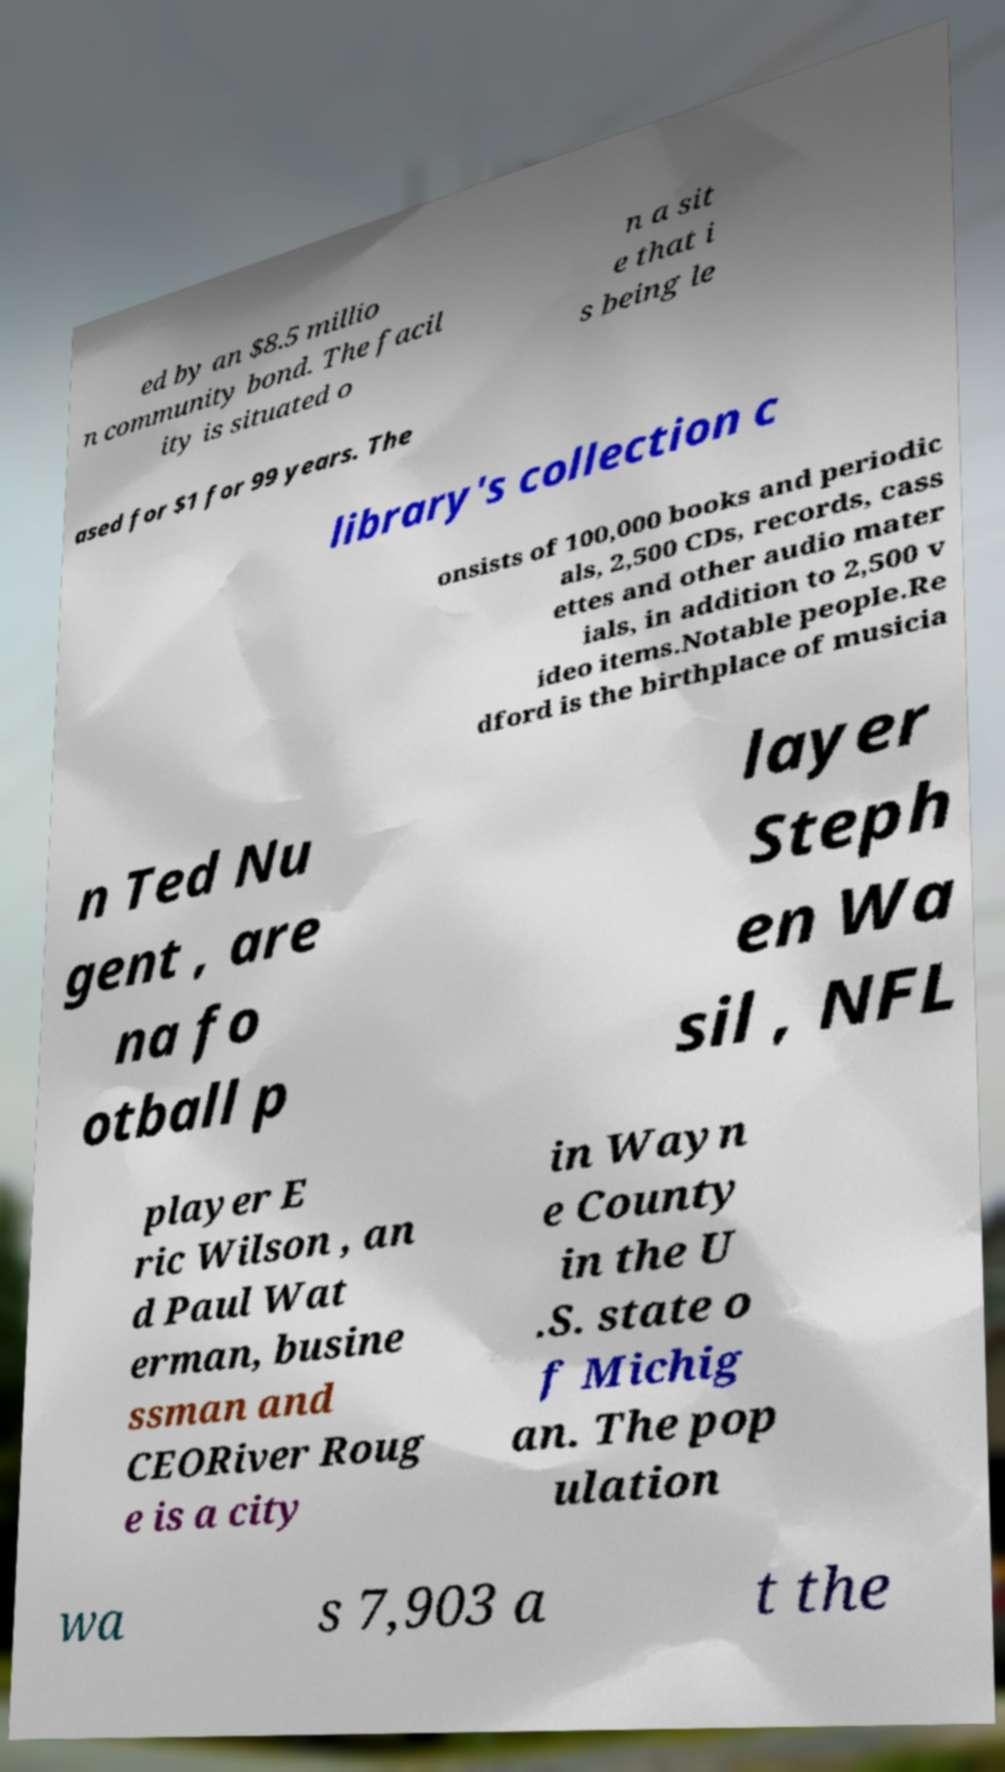I need the written content from this picture converted into text. Can you do that? ed by an $8.5 millio n community bond. The facil ity is situated o n a sit e that i s being le ased for $1 for 99 years. The library's collection c onsists of 100,000 books and periodic als, 2,500 CDs, records, cass ettes and other audio mater ials, in addition to 2,500 v ideo items.Notable people.Re dford is the birthplace of musicia n Ted Nu gent , are na fo otball p layer Steph en Wa sil , NFL player E ric Wilson , an d Paul Wat erman, busine ssman and CEORiver Roug e is a city in Wayn e County in the U .S. state o f Michig an. The pop ulation wa s 7,903 a t the 